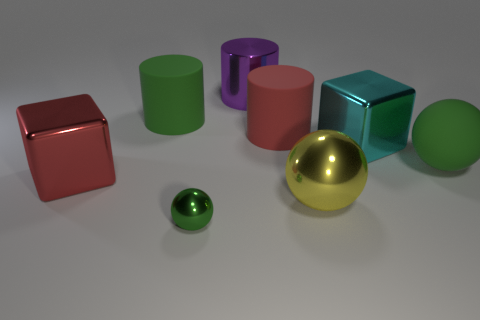Subtract all big purple cylinders. How many cylinders are left? 2 Subtract all red cubes. How many green spheres are left? 2 Add 2 large objects. How many objects exist? 10 Subtract all balls. How many objects are left? 5 Subtract all blue spheres. Subtract all red cylinders. How many spheres are left? 3 Add 2 cyan shiny things. How many cyan shiny things are left? 3 Add 4 purple things. How many purple things exist? 5 Subtract 0 blue blocks. How many objects are left? 8 Subtract all large blue rubber spheres. Subtract all purple objects. How many objects are left? 7 